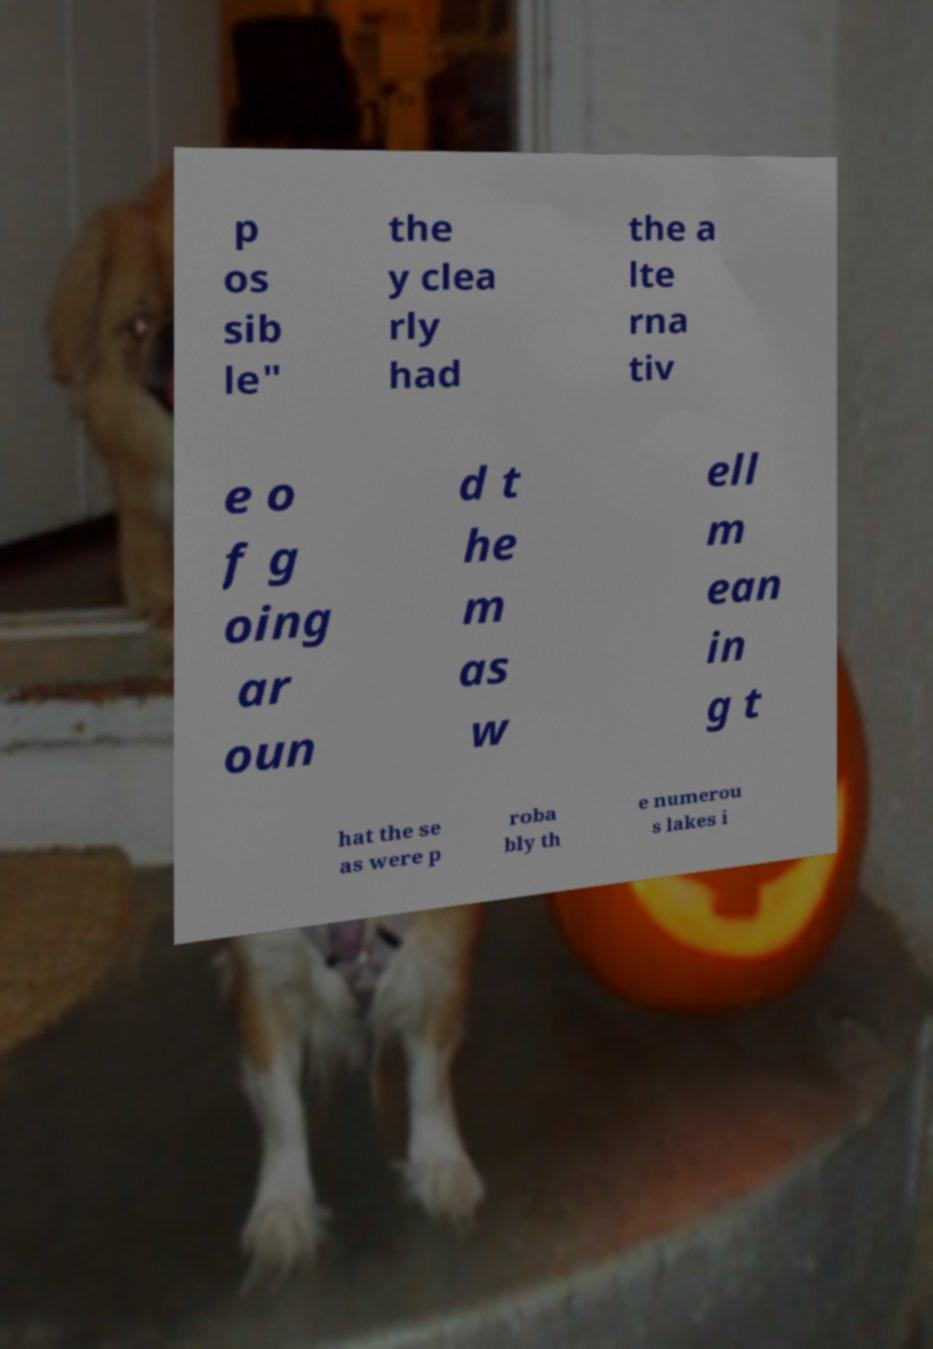Can you accurately transcribe the text from the provided image for me? p os sib le" the y clea rly had the a lte rna tiv e o f g oing ar oun d t he m as w ell m ean in g t hat the se as were p roba bly th e numerou s lakes i 